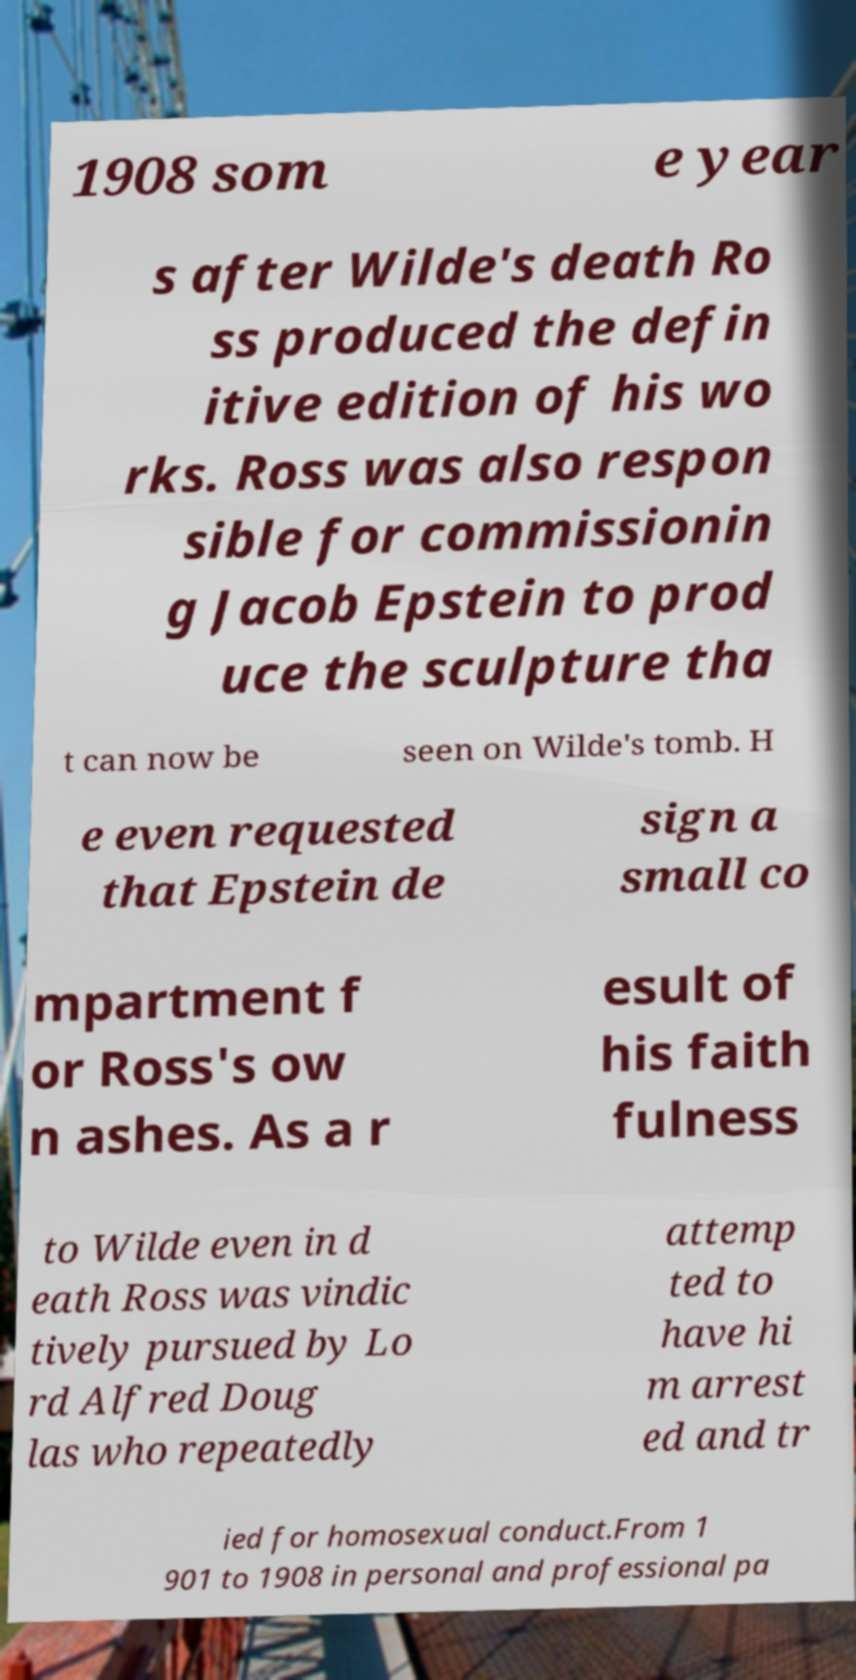Can you accurately transcribe the text from the provided image for me? 1908 som e year s after Wilde's death Ro ss produced the defin itive edition of his wo rks. Ross was also respon sible for commissionin g Jacob Epstein to prod uce the sculpture tha t can now be seen on Wilde's tomb. H e even requested that Epstein de sign a small co mpartment f or Ross's ow n ashes. As a r esult of his faith fulness to Wilde even in d eath Ross was vindic tively pursued by Lo rd Alfred Doug las who repeatedly attemp ted to have hi m arrest ed and tr ied for homosexual conduct.From 1 901 to 1908 in personal and professional pa 